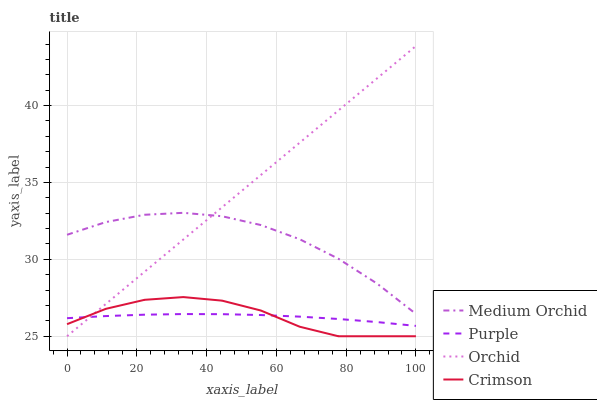Does Purple have the minimum area under the curve?
Answer yes or no. Yes. Does Orchid have the maximum area under the curve?
Answer yes or no. Yes. Does Crimson have the minimum area under the curve?
Answer yes or no. No. Does Crimson have the maximum area under the curve?
Answer yes or no. No. Is Orchid the smoothest?
Answer yes or no. Yes. Is Crimson the roughest?
Answer yes or no. Yes. Is Medium Orchid the smoothest?
Answer yes or no. No. Is Medium Orchid the roughest?
Answer yes or no. No. Does Crimson have the lowest value?
Answer yes or no. Yes. Does Medium Orchid have the lowest value?
Answer yes or no. No. Does Orchid have the highest value?
Answer yes or no. Yes. Does Crimson have the highest value?
Answer yes or no. No. Is Crimson less than Medium Orchid?
Answer yes or no. Yes. Is Medium Orchid greater than Purple?
Answer yes or no. Yes. Does Orchid intersect Medium Orchid?
Answer yes or no. Yes. Is Orchid less than Medium Orchid?
Answer yes or no. No. Is Orchid greater than Medium Orchid?
Answer yes or no. No. Does Crimson intersect Medium Orchid?
Answer yes or no. No. 